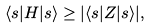<formula> <loc_0><loc_0><loc_500><loc_500>\langle s | H | s \rangle \geq | \langle s | Z | s \rangle | ,</formula> 